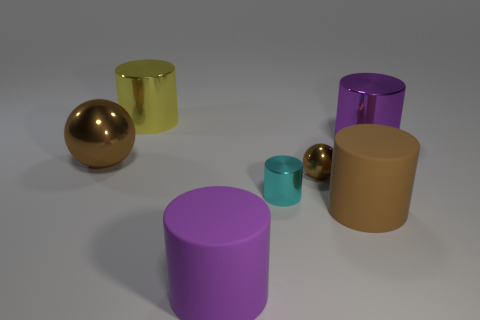How many other objects are there of the same color as the small sphere?
Provide a succinct answer. 2. Are there fewer purple metallic things in front of the brown rubber object than brown metallic balls that are on the right side of the tiny cyan shiny cylinder?
Your answer should be very brief. Yes. How many things are either cylinders left of the cyan metal cylinder or large green rubber cylinders?
Your answer should be very brief. 2. Does the yellow thing have the same size as the metal ball that is behind the tiny brown thing?
Your answer should be compact. Yes. What is the size of the brown object that is the same shape as the purple matte object?
Offer a very short reply. Large. There is a big metal sphere that is in front of the big purple metal object behind the brown cylinder; what number of large brown objects are in front of it?
Provide a short and direct response. 1. What number of spheres are purple metal objects or small yellow metallic things?
Make the answer very short. 0. What is the color of the sphere in front of the brown object that is left of the big cylinder behind the purple metal cylinder?
Your answer should be very brief. Brown. How many other objects are the same size as the yellow shiny object?
Give a very brief answer. 4. There is a tiny metallic thing that is the same shape as the big purple rubber object; what color is it?
Offer a very short reply. Cyan. 